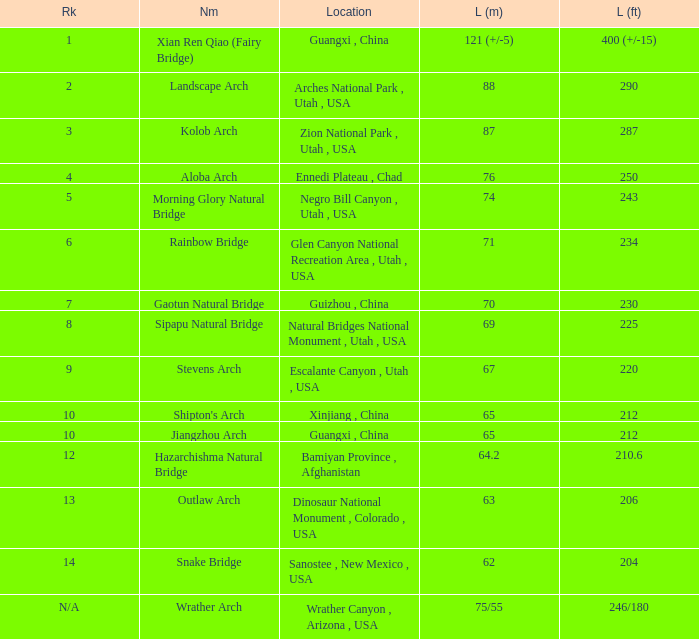2-meter-long arch with the greatest length located? Bamiyan Province , Afghanistan. 